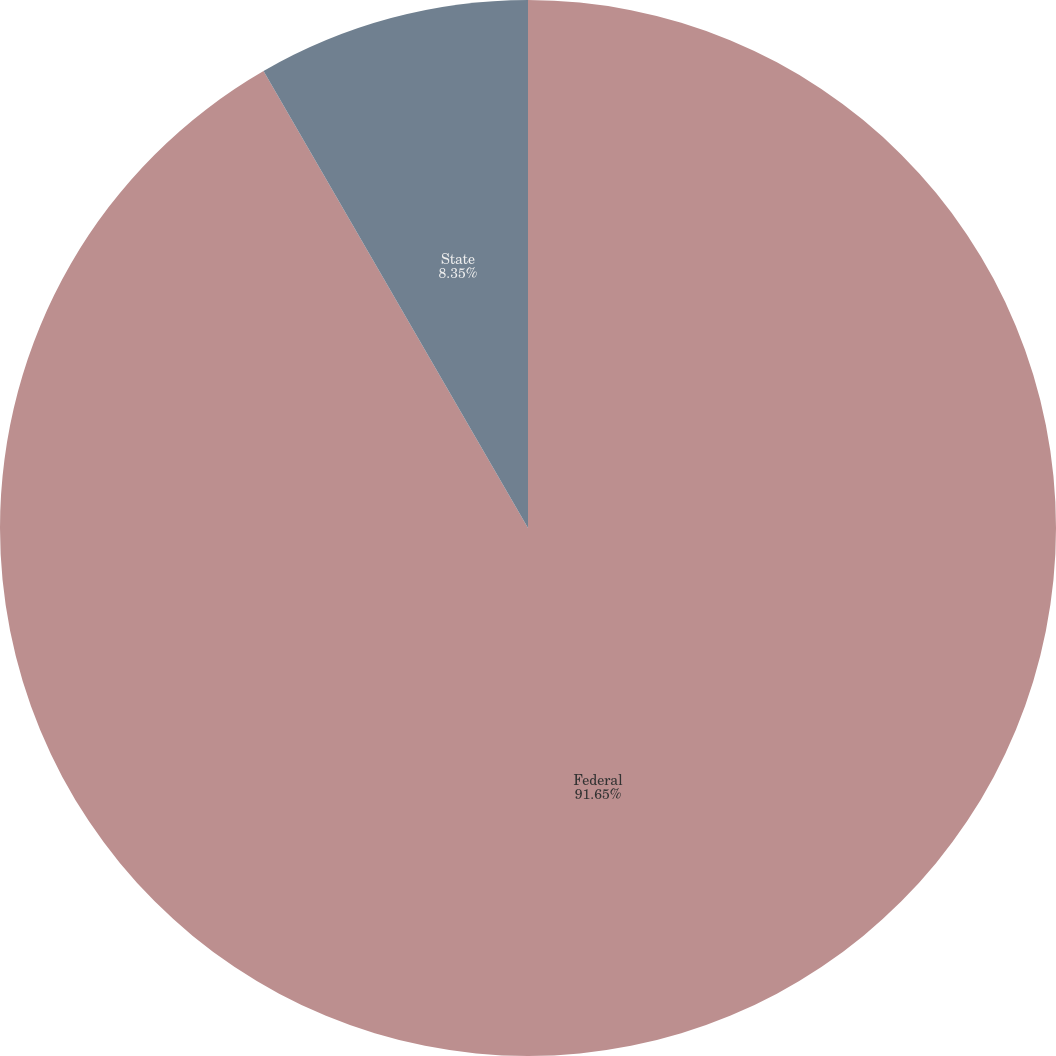Convert chart to OTSL. <chart><loc_0><loc_0><loc_500><loc_500><pie_chart><fcel>Federal<fcel>State<nl><fcel>91.65%<fcel>8.35%<nl></chart> 